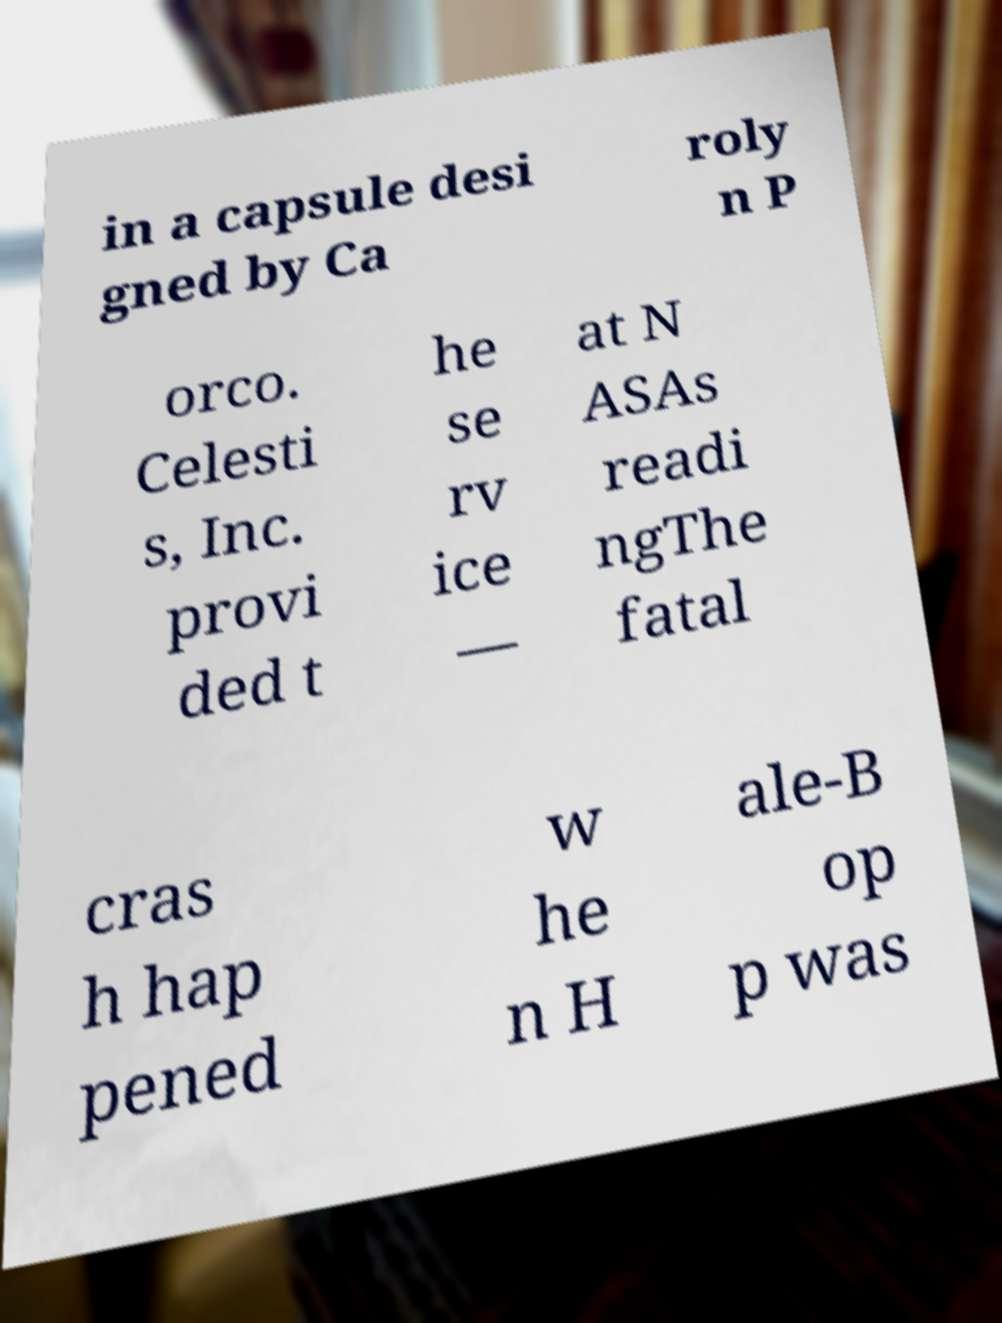Please read and relay the text visible in this image. What does it say? in a capsule desi gned by Ca roly n P orco. Celesti s, Inc. provi ded t he se rv ice — at N ASAs readi ngThe fatal cras h hap pened w he n H ale-B op p was 